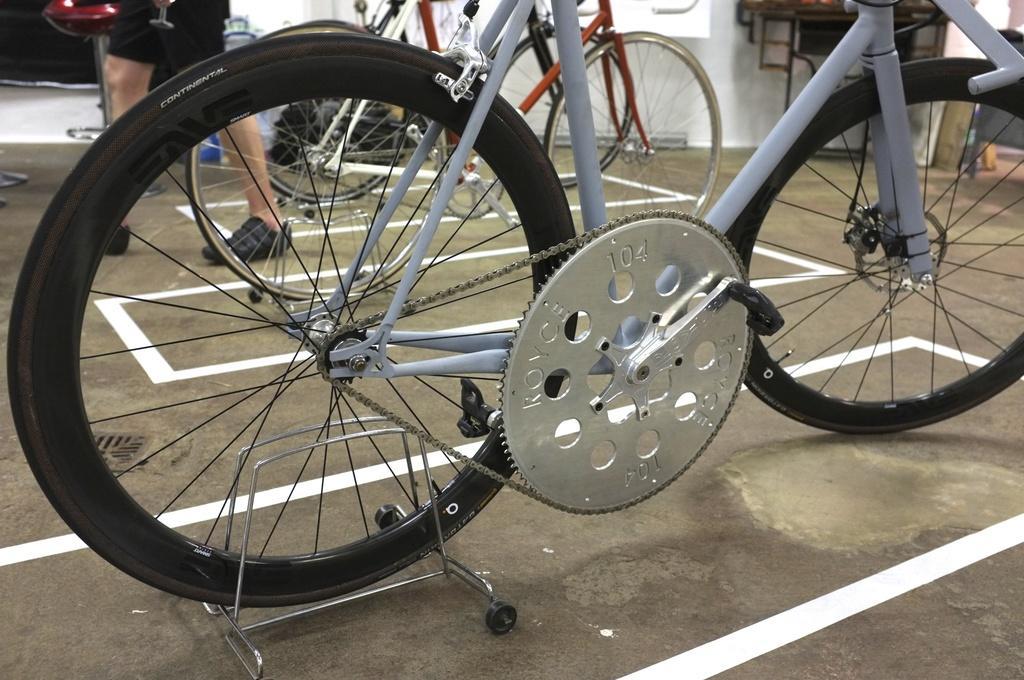How would you summarize this image in a sentence or two? In this picture I can see bicycles, there is a person standing, and there are some other objects. 